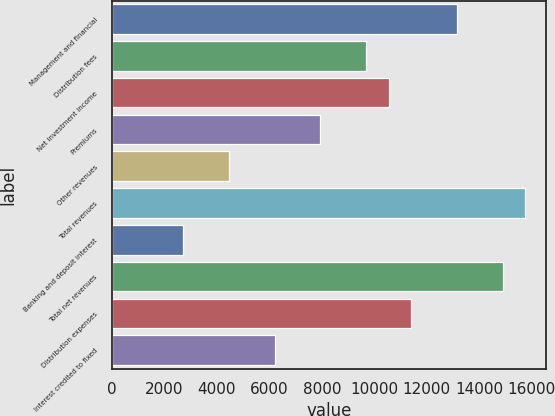<chart> <loc_0><loc_0><loc_500><loc_500><bar_chart><fcel>Management and financial<fcel>Distribution fees<fcel>Net investment income<fcel>Premiums<fcel>Other revenues<fcel>Total revenues<fcel>Banking and deposit interest<fcel>Total net revenues<fcel>Distribution expenses<fcel>Interest credited to fixed<nl><fcel>13151.5<fcel>9674.3<fcel>10543.6<fcel>7935.7<fcel>4458.5<fcel>15759.4<fcel>2719.9<fcel>14890.1<fcel>11412.9<fcel>6197.1<nl></chart> 